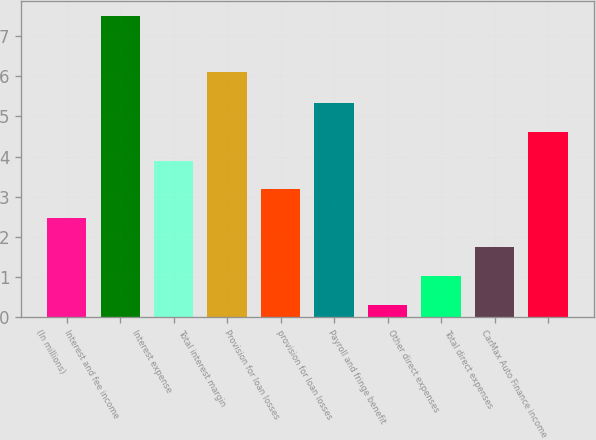Convert chart to OTSL. <chart><loc_0><loc_0><loc_500><loc_500><bar_chart><fcel>(In millions)<fcel>Interest and fee income<fcel>Interest expense<fcel>Total interest margin<fcel>Provision for loan losses<fcel>provision for loan losses<fcel>Payroll and fringe benefit<fcel>Other direct expenses<fcel>Total direct expenses<fcel>CarMax Auto Finance income<nl><fcel>2.46<fcel>7.5<fcel>3.9<fcel>6.1<fcel>3.18<fcel>5.34<fcel>0.3<fcel>1.02<fcel>1.74<fcel>4.62<nl></chart> 